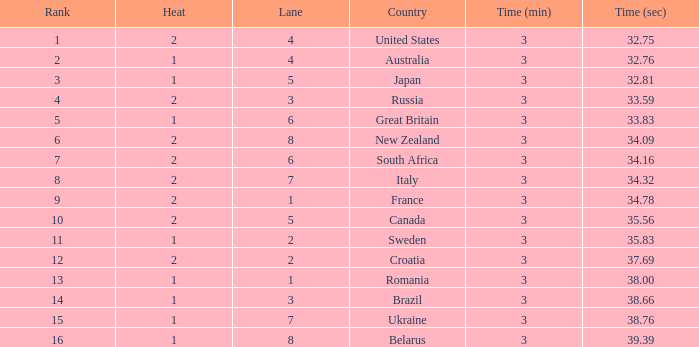Can you tell me the Rank that has the Lane of 6, and the Heat of 2? 7.0. Could you parse the entire table? {'header': ['Rank', 'Heat', 'Lane', 'Country', 'Time (min)', 'Time (sec)'], 'rows': [['1', '2', '4', 'United States', '3', '32.75'], ['2', '1', '4', 'Australia', '3', '32.76'], ['3', '1', '5', 'Japan', '3', '32.81'], ['4', '2', '3', 'Russia', '3', '33.59'], ['5', '1', '6', 'Great Britain', '3', '33.83'], ['6', '2', '8', 'New Zealand', '3', '34.09'], ['7', '2', '6', 'South Africa', '3', '34.16'], ['8', '2', '7', 'Italy', '3', '34.32'], ['9', '2', '1', 'France', '3', '34.78'], ['10', '2', '5', 'Canada', '3', '35.56'], ['11', '1', '2', 'Sweden', '3', '35.83'], ['12', '2', '2', 'Croatia', '3', '37.69'], ['13', '1', '1', 'Romania', '3', '38.00'], ['14', '1', '3', 'Brazil', '3', '38.66'], ['15', '1', '7', 'Ukraine', '3', '38.76'], ['16', '1', '8', 'Belarus', '3', '39.39']]} 